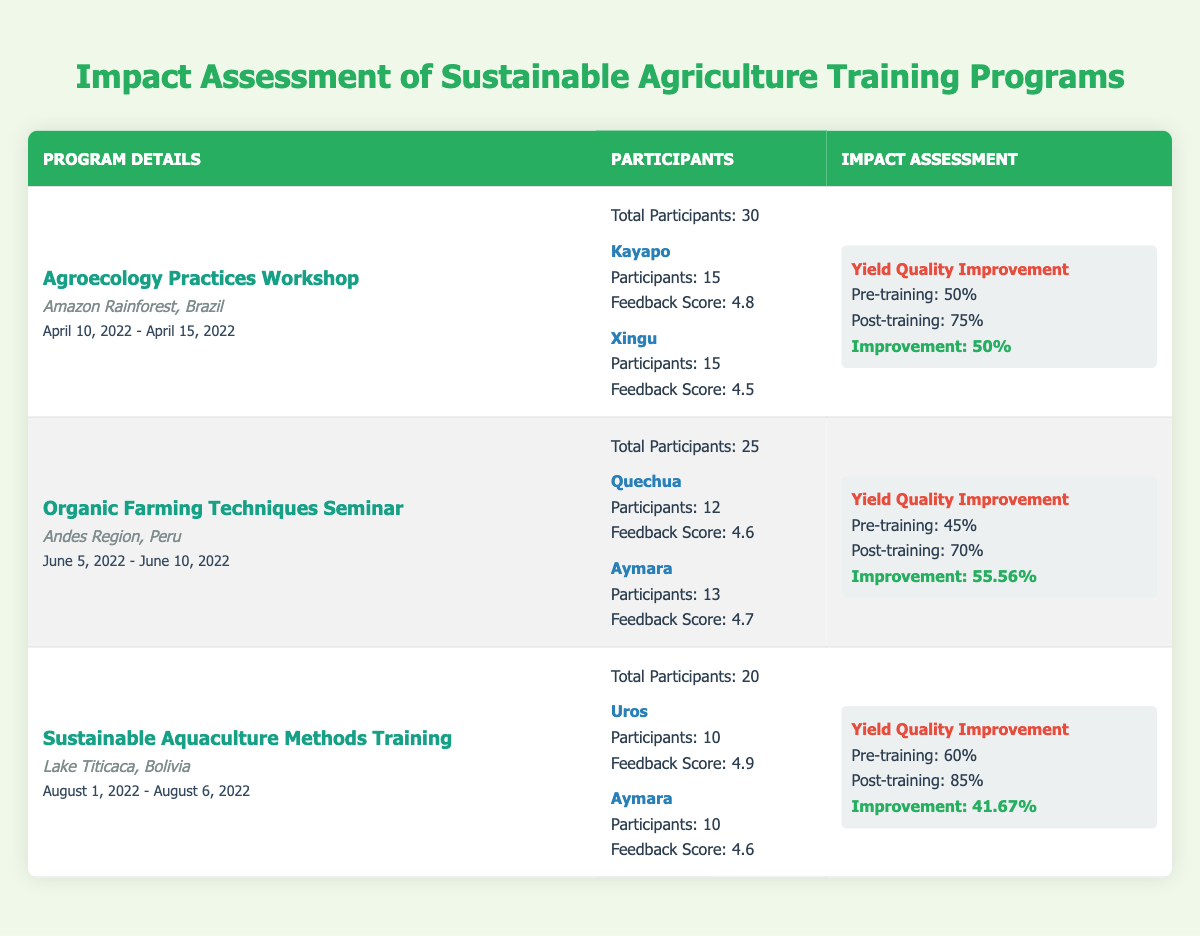What is the maximum feedback score received by any community in the training programs? The table shows feedback scores for all communities involved in the training programs. The highest score listed is 4.9 from the Uros community during the Sustainable Aquaculture Methods Training.
Answer: 4.9 Which program had the highest percentage of yield quality improvement? To find the program with the highest improvement, we compare the Improvement Percentage of each program: Agroecology Practices Workshop (50%), Organic Farming Techniques Seminar (55.56%), and Sustainable Aquaculture Methods Training (41.67%). The Organic Farming Techniques Seminar has the highest improvement at 55.56%.
Answer: Organic Farming Techniques Seminar How many total participants attended the Agroecology Practices Workshop? The Agroecology Practices Workshop had a total of 30 participants, as indicated in the Participants section of the table.
Answer: 30 Did the Uros community receive a feedback score lower than 4.5 in any training program? The Uros community received a feedback score of 4.9 in the Sustainable Aquaculture Methods Training, which is higher than 4.5. Thus, they did not have a score lower than 4.5 in this program.
Answer: No What is the average feedback score for communities that participated in the Organic Farming Techniques Seminar? The seminar included two communities: Quechua with a score of 4.6 and Aymara with a score of 4.7. The average is calculated as (4.6 + 4.7) / 2 = 4.65.
Answer: 4.65 Which program's participants experienced the smallest improvement in yield quality? Comparing the yield quality improvements: Agroecology Practices Workshop (50%), Organic Farming Techniques Seminar (55.56%), and Sustainable Aquaculture Methods Training (41.67%). The Sustainable Aquaculture Methods Training program had the smallest improvement at 41.67%.
Answer: Sustainable Aquaculture Methods Training How many participants were from Indigenous communities in total across all programs? The total Indigenous community participants from each program can be calculated: Agroecology Practices Workshop (30), Organic Farming Techniques Seminar (25), and Sustainable Aquaculture Methods Training (20). Summing these gives 30 + 25 + 20 = 75 participants from Indigenous communities in total.
Answer: 75 What was the yield quality before training in the Organic Farming Techniques Seminar? The Pre-training Yield Quality for the Organic Farming Techniques Seminar is listed as 45% in the Impact Assessment section of the table.
Answer: 45% 